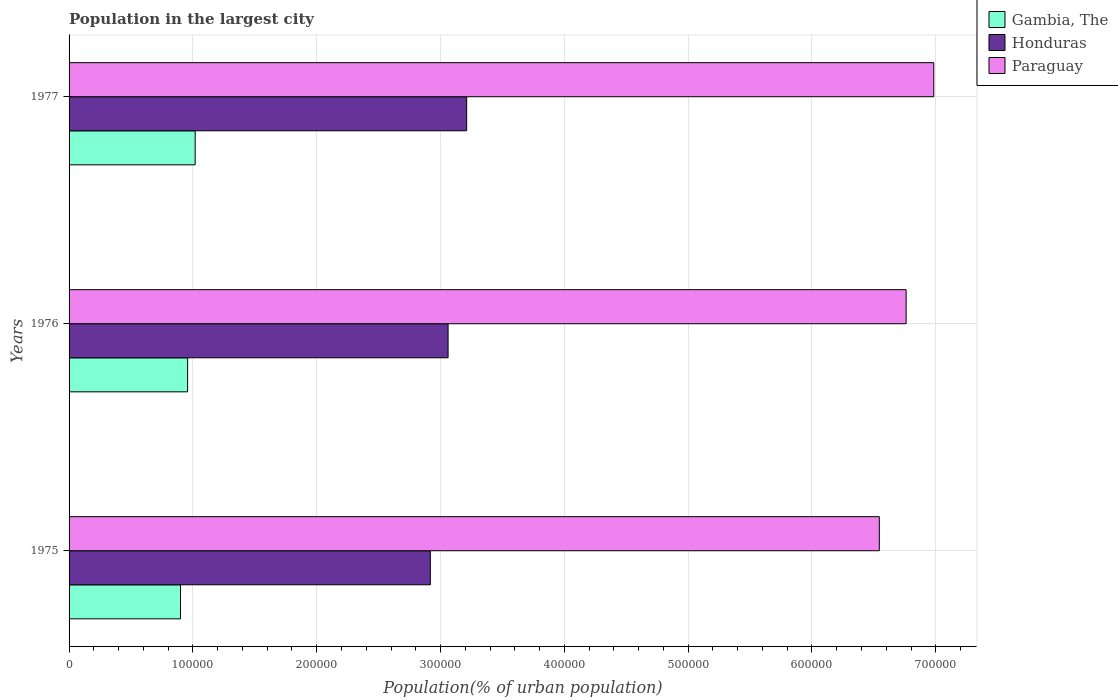How many groups of bars are there?
Offer a terse response. 3. How many bars are there on the 3rd tick from the bottom?
Your answer should be compact. 3. What is the label of the 2nd group of bars from the top?
Make the answer very short. 1976. What is the population in the largest city in Honduras in 1976?
Provide a short and direct response. 3.06e+05. Across all years, what is the maximum population in the largest city in Paraguay?
Your response must be concise. 6.98e+05. Across all years, what is the minimum population in the largest city in Paraguay?
Provide a succinct answer. 6.54e+05. In which year was the population in the largest city in Gambia, The maximum?
Offer a very short reply. 1977. In which year was the population in the largest city in Paraguay minimum?
Give a very brief answer. 1975. What is the total population in the largest city in Honduras in the graph?
Provide a succinct answer. 9.19e+05. What is the difference between the population in the largest city in Honduras in 1975 and that in 1976?
Make the answer very short. -1.43e+04. What is the difference between the population in the largest city in Honduras in 1975 and the population in the largest city in Gambia, The in 1976?
Give a very brief answer. 1.96e+05. What is the average population in the largest city in Gambia, The per year?
Give a very brief answer. 9.59e+04. In the year 1976, what is the difference between the population in the largest city in Paraguay and population in the largest city in Honduras?
Provide a short and direct response. 3.70e+05. What is the ratio of the population in the largest city in Gambia, The in 1975 to that in 1976?
Provide a short and direct response. 0.94. What is the difference between the highest and the second highest population in the largest city in Honduras?
Give a very brief answer. 1.50e+04. What is the difference between the highest and the lowest population in the largest city in Gambia, The?
Provide a succinct answer. 1.18e+04. In how many years, is the population in the largest city in Paraguay greater than the average population in the largest city in Paraguay taken over all years?
Your answer should be compact. 1. What does the 3rd bar from the top in 1977 represents?
Provide a short and direct response. Gambia, The. What does the 1st bar from the bottom in 1975 represents?
Your answer should be compact. Gambia, The. Is it the case that in every year, the sum of the population in the largest city in Gambia, The and population in the largest city in Honduras is greater than the population in the largest city in Paraguay?
Offer a very short reply. No. How many bars are there?
Your answer should be compact. 9. Are all the bars in the graph horizontal?
Keep it short and to the point. Yes. What is the difference between two consecutive major ticks on the X-axis?
Your answer should be compact. 1.00e+05. Does the graph contain any zero values?
Offer a terse response. No. Does the graph contain grids?
Your response must be concise. Yes. How many legend labels are there?
Give a very brief answer. 3. How are the legend labels stacked?
Make the answer very short. Vertical. What is the title of the graph?
Keep it short and to the point. Population in the largest city. What is the label or title of the X-axis?
Keep it short and to the point. Population(% of urban population). What is the Population(% of urban population) in Honduras in 1975?
Provide a short and direct response. 2.92e+05. What is the Population(% of urban population) of Paraguay in 1975?
Your answer should be compact. 6.54e+05. What is the Population(% of urban population) of Gambia, The in 1976?
Make the answer very short. 9.58e+04. What is the Population(% of urban population) in Honduras in 1976?
Keep it short and to the point. 3.06e+05. What is the Population(% of urban population) in Paraguay in 1976?
Offer a terse response. 6.76e+05. What is the Population(% of urban population) of Gambia, The in 1977?
Your answer should be compact. 1.02e+05. What is the Population(% of urban population) in Honduras in 1977?
Make the answer very short. 3.21e+05. What is the Population(% of urban population) of Paraguay in 1977?
Offer a terse response. 6.98e+05. Across all years, what is the maximum Population(% of urban population) in Gambia, The?
Offer a terse response. 1.02e+05. Across all years, what is the maximum Population(% of urban population) of Honduras?
Offer a terse response. 3.21e+05. Across all years, what is the maximum Population(% of urban population) of Paraguay?
Offer a very short reply. 6.98e+05. Across all years, what is the minimum Population(% of urban population) of Honduras?
Keep it short and to the point. 2.92e+05. Across all years, what is the minimum Population(% of urban population) of Paraguay?
Give a very brief answer. 6.54e+05. What is the total Population(% of urban population) in Gambia, The in the graph?
Provide a succinct answer. 2.88e+05. What is the total Population(% of urban population) in Honduras in the graph?
Your answer should be compact. 9.19e+05. What is the total Population(% of urban population) of Paraguay in the graph?
Your answer should be very brief. 2.03e+06. What is the difference between the Population(% of urban population) of Gambia, The in 1975 and that in 1976?
Provide a succinct answer. -5750. What is the difference between the Population(% of urban population) in Honduras in 1975 and that in 1976?
Ensure brevity in your answer.  -1.43e+04. What is the difference between the Population(% of urban population) of Paraguay in 1975 and that in 1976?
Give a very brief answer. -2.17e+04. What is the difference between the Population(% of urban population) of Gambia, The in 1975 and that in 1977?
Keep it short and to the point. -1.18e+04. What is the difference between the Population(% of urban population) in Honduras in 1975 and that in 1977?
Your response must be concise. -2.93e+04. What is the difference between the Population(% of urban population) of Paraguay in 1975 and that in 1977?
Provide a succinct answer. -4.40e+04. What is the difference between the Population(% of urban population) of Gambia, The in 1976 and that in 1977?
Ensure brevity in your answer.  -6100. What is the difference between the Population(% of urban population) in Honduras in 1976 and that in 1977?
Offer a very short reply. -1.50e+04. What is the difference between the Population(% of urban population) of Paraguay in 1976 and that in 1977?
Give a very brief answer. -2.23e+04. What is the difference between the Population(% of urban population) in Gambia, The in 1975 and the Population(% of urban population) in Honduras in 1976?
Offer a terse response. -2.16e+05. What is the difference between the Population(% of urban population) in Gambia, The in 1975 and the Population(% of urban population) in Paraguay in 1976?
Your response must be concise. -5.86e+05. What is the difference between the Population(% of urban population) of Honduras in 1975 and the Population(% of urban population) of Paraguay in 1976?
Your answer should be very brief. -3.84e+05. What is the difference between the Population(% of urban population) in Gambia, The in 1975 and the Population(% of urban population) in Honduras in 1977?
Give a very brief answer. -2.31e+05. What is the difference between the Population(% of urban population) of Gambia, The in 1975 and the Population(% of urban population) of Paraguay in 1977?
Provide a short and direct response. -6.08e+05. What is the difference between the Population(% of urban population) of Honduras in 1975 and the Population(% of urban population) of Paraguay in 1977?
Offer a terse response. -4.07e+05. What is the difference between the Population(% of urban population) in Gambia, The in 1976 and the Population(% of urban population) in Honduras in 1977?
Your answer should be very brief. -2.25e+05. What is the difference between the Population(% of urban population) of Gambia, The in 1976 and the Population(% of urban population) of Paraguay in 1977?
Offer a terse response. -6.03e+05. What is the difference between the Population(% of urban population) of Honduras in 1976 and the Population(% of urban population) of Paraguay in 1977?
Offer a very short reply. -3.92e+05. What is the average Population(% of urban population) of Gambia, The per year?
Keep it short and to the point. 9.59e+04. What is the average Population(% of urban population) of Honduras per year?
Offer a terse response. 3.06e+05. What is the average Population(% of urban population) of Paraguay per year?
Offer a very short reply. 6.76e+05. In the year 1975, what is the difference between the Population(% of urban population) of Gambia, The and Population(% of urban population) of Honduras?
Provide a succinct answer. -2.02e+05. In the year 1975, what is the difference between the Population(% of urban population) of Gambia, The and Population(% of urban population) of Paraguay?
Ensure brevity in your answer.  -5.64e+05. In the year 1975, what is the difference between the Population(% of urban population) of Honduras and Population(% of urban population) of Paraguay?
Make the answer very short. -3.63e+05. In the year 1976, what is the difference between the Population(% of urban population) of Gambia, The and Population(% of urban population) of Honduras?
Make the answer very short. -2.10e+05. In the year 1976, what is the difference between the Population(% of urban population) in Gambia, The and Population(% of urban population) in Paraguay?
Your answer should be compact. -5.80e+05. In the year 1976, what is the difference between the Population(% of urban population) of Honduras and Population(% of urban population) of Paraguay?
Provide a succinct answer. -3.70e+05. In the year 1977, what is the difference between the Population(% of urban population) of Gambia, The and Population(% of urban population) of Honduras?
Give a very brief answer. -2.19e+05. In the year 1977, what is the difference between the Population(% of urban population) of Gambia, The and Population(% of urban population) of Paraguay?
Offer a very short reply. -5.96e+05. In the year 1977, what is the difference between the Population(% of urban population) in Honduras and Population(% of urban population) in Paraguay?
Make the answer very short. -3.77e+05. What is the ratio of the Population(% of urban population) in Gambia, The in 1975 to that in 1976?
Your response must be concise. 0.94. What is the ratio of the Population(% of urban population) in Honduras in 1975 to that in 1976?
Provide a succinct answer. 0.95. What is the ratio of the Population(% of urban population) of Gambia, The in 1975 to that in 1977?
Provide a succinct answer. 0.88. What is the ratio of the Population(% of urban population) of Honduras in 1975 to that in 1977?
Ensure brevity in your answer.  0.91. What is the ratio of the Population(% of urban population) in Paraguay in 1975 to that in 1977?
Your answer should be very brief. 0.94. What is the ratio of the Population(% of urban population) of Gambia, The in 1976 to that in 1977?
Give a very brief answer. 0.94. What is the ratio of the Population(% of urban population) in Honduras in 1976 to that in 1977?
Provide a succinct answer. 0.95. What is the ratio of the Population(% of urban population) of Paraguay in 1976 to that in 1977?
Your answer should be compact. 0.97. What is the difference between the highest and the second highest Population(% of urban population) of Gambia, The?
Ensure brevity in your answer.  6100. What is the difference between the highest and the second highest Population(% of urban population) of Honduras?
Your answer should be compact. 1.50e+04. What is the difference between the highest and the second highest Population(% of urban population) in Paraguay?
Your answer should be very brief. 2.23e+04. What is the difference between the highest and the lowest Population(% of urban population) in Gambia, The?
Your answer should be compact. 1.18e+04. What is the difference between the highest and the lowest Population(% of urban population) in Honduras?
Your answer should be compact. 2.93e+04. What is the difference between the highest and the lowest Population(% of urban population) in Paraguay?
Make the answer very short. 4.40e+04. 